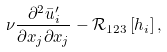Convert formula to latex. <formula><loc_0><loc_0><loc_500><loc_500>\nu \frac { \partial ^ { 2 } { \bar { u } } ^ { \prime } _ { i } } { \partial x _ { j } \partial x _ { j } } - { \mathcal { R } } _ { 1 2 3 } \left [ { h _ { i } } \right ] ,</formula> 